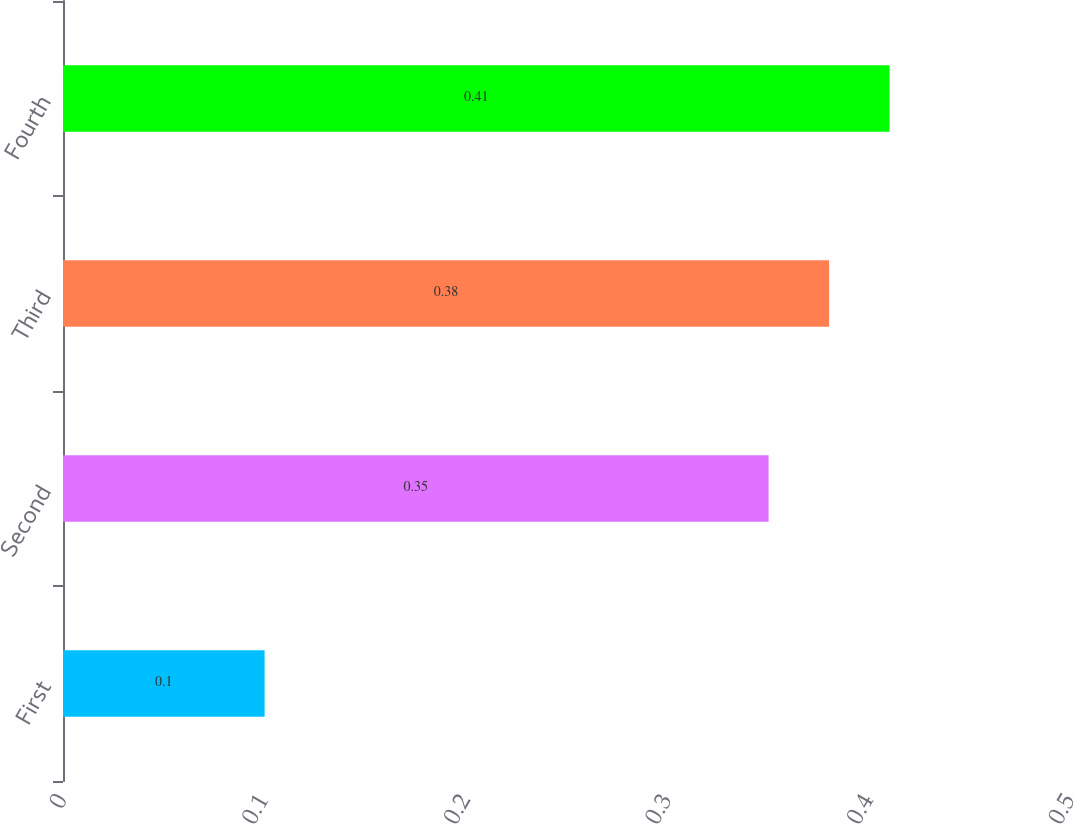<chart> <loc_0><loc_0><loc_500><loc_500><bar_chart><fcel>First<fcel>Second<fcel>Third<fcel>Fourth<nl><fcel>0.1<fcel>0.35<fcel>0.38<fcel>0.41<nl></chart> 